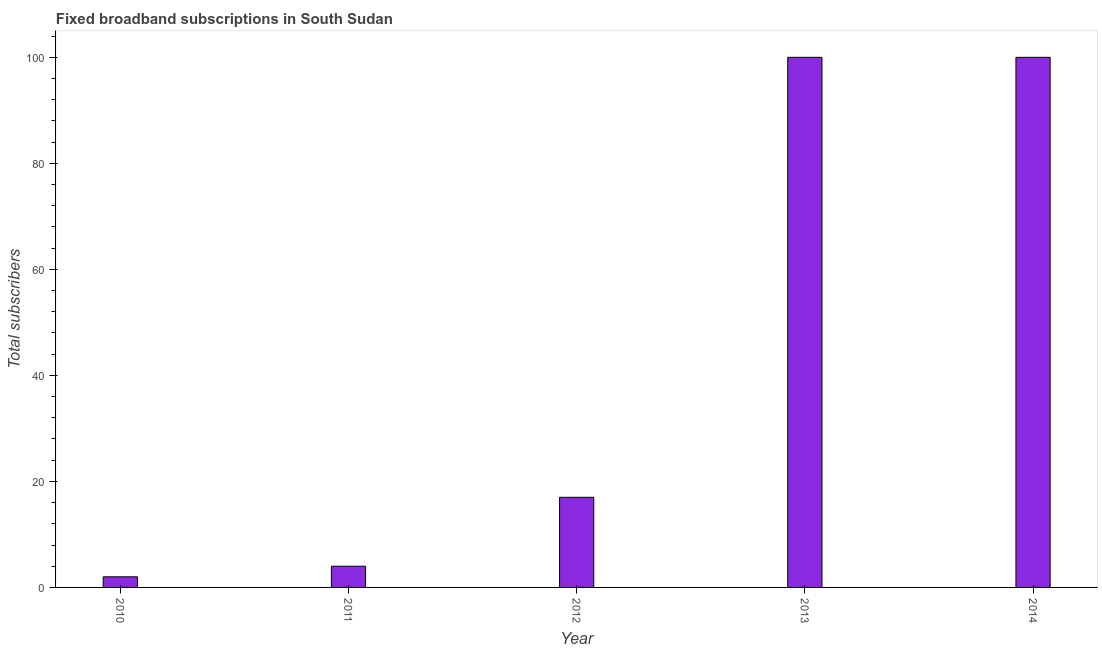Does the graph contain any zero values?
Provide a short and direct response. No. What is the title of the graph?
Provide a succinct answer. Fixed broadband subscriptions in South Sudan. What is the label or title of the Y-axis?
Provide a short and direct response. Total subscribers. Across all years, what is the maximum total number of fixed broadband subscriptions?
Offer a terse response. 100. Across all years, what is the minimum total number of fixed broadband subscriptions?
Your response must be concise. 2. What is the sum of the total number of fixed broadband subscriptions?
Keep it short and to the point. 223. What is the difference between the total number of fixed broadband subscriptions in 2011 and 2012?
Provide a succinct answer. -13. What is the median total number of fixed broadband subscriptions?
Keep it short and to the point. 17. Do a majority of the years between 2014 and 2011 (inclusive) have total number of fixed broadband subscriptions greater than 76 ?
Your response must be concise. Yes. What is the ratio of the total number of fixed broadband subscriptions in 2010 to that in 2014?
Give a very brief answer. 0.02. Is the total number of fixed broadband subscriptions in 2012 less than that in 2014?
Give a very brief answer. Yes. Is the difference between the total number of fixed broadband subscriptions in 2013 and 2014 greater than the difference between any two years?
Keep it short and to the point. No. Is the sum of the total number of fixed broadband subscriptions in 2012 and 2013 greater than the maximum total number of fixed broadband subscriptions across all years?
Provide a short and direct response. Yes. How many bars are there?
Offer a terse response. 5. What is the Total subscribers in 2010?
Give a very brief answer. 2. What is the Total subscribers of 2011?
Make the answer very short. 4. What is the Total subscribers of 2013?
Provide a succinct answer. 100. What is the difference between the Total subscribers in 2010 and 2012?
Your response must be concise. -15. What is the difference between the Total subscribers in 2010 and 2013?
Ensure brevity in your answer.  -98. What is the difference between the Total subscribers in 2010 and 2014?
Offer a very short reply. -98. What is the difference between the Total subscribers in 2011 and 2013?
Make the answer very short. -96. What is the difference between the Total subscribers in 2011 and 2014?
Offer a very short reply. -96. What is the difference between the Total subscribers in 2012 and 2013?
Your response must be concise. -83. What is the difference between the Total subscribers in 2012 and 2014?
Make the answer very short. -83. What is the difference between the Total subscribers in 2013 and 2014?
Your response must be concise. 0. What is the ratio of the Total subscribers in 2010 to that in 2012?
Give a very brief answer. 0.12. What is the ratio of the Total subscribers in 2011 to that in 2012?
Your answer should be very brief. 0.23. What is the ratio of the Total subscribers in 2011 to that in 2014?
Provide a succinct answer. 0.04. What is the ratio of the Total subscribers in 2012 to that in 2013?
Offer a very short reply. 0.17. What is the ratio of the Total subscribers in 2012 to that in 2014?
Offer a very short reply. 0.17. 